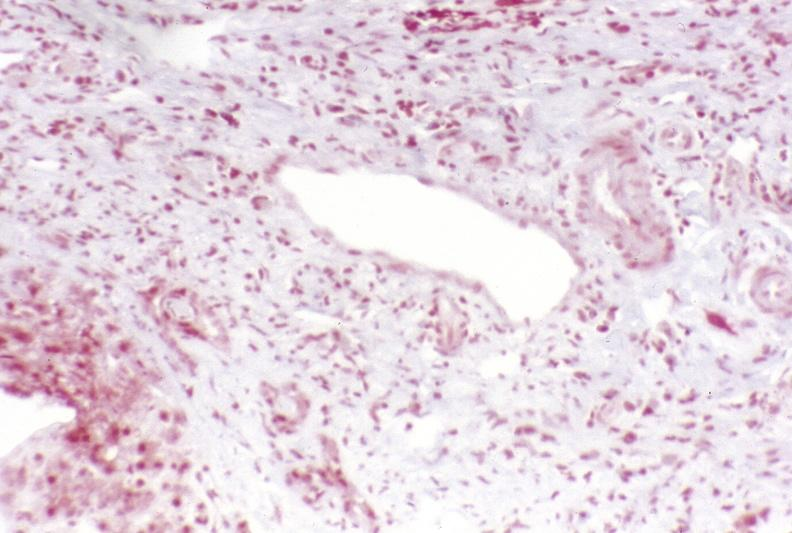what does this image show?
Answer the question using a single word or phrase. Primary sclerosing cholangitis 